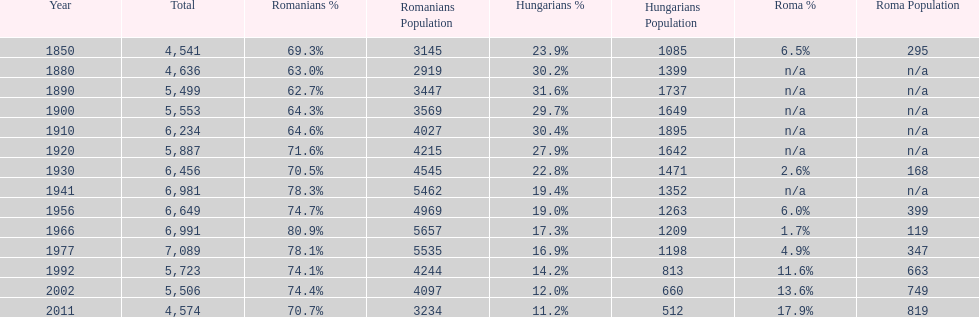What were the total number of times the romanians had a population percentage above 70%? 9. 